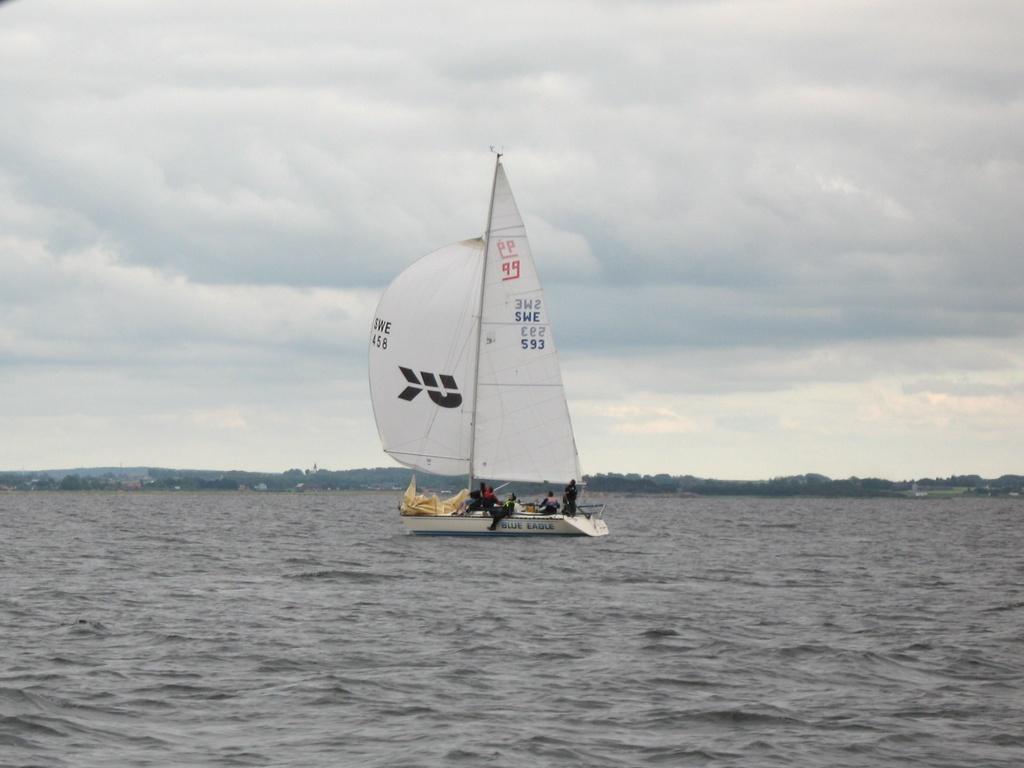How would you summarize this image in a sentence or two? In this picture there is a boat on the water. There are group of people sitting on the boat. At the back there are trees. At the top there is sky and there are clouds. At the bottom there is water. 